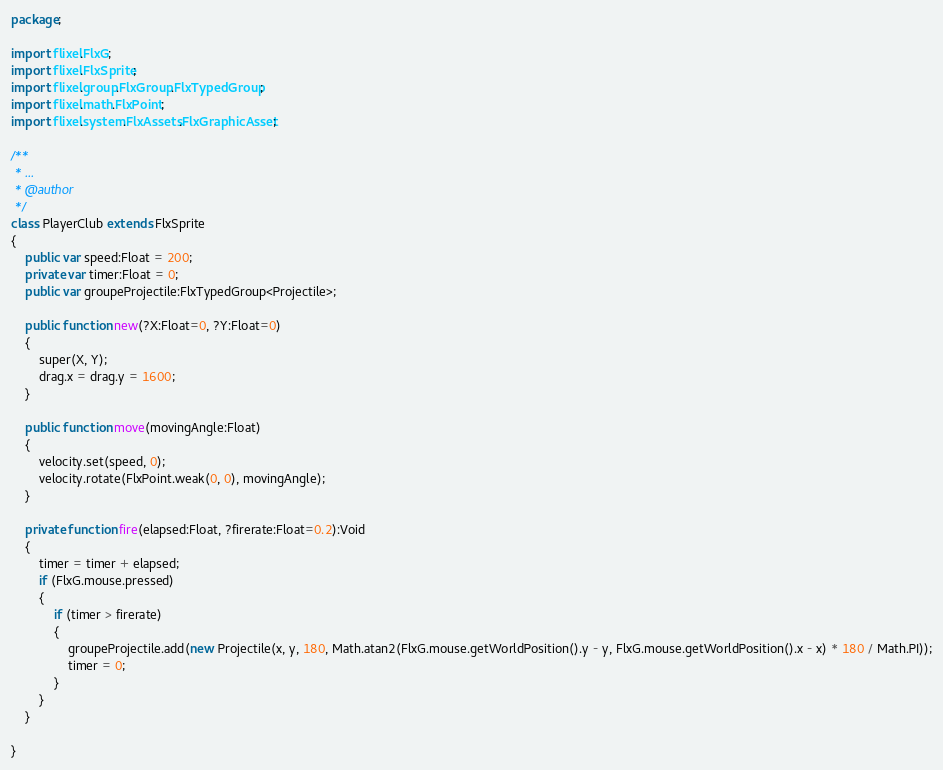Convert code to text. <code><loc_0><loc_0><loc_500><loc_500><_Haxe_>package;

import flixel.FlxG;
import flixel.FlxSprite;
import flixel.group.FlxGroup.FlxTypedGroup;
import flixel.math.FlxPoint;
import flixel.system.FlxAssets.FlxGraphicAsset;

/**
 * ...
 * @author 
 */
class PlayerClub extends FlxSprite 
{
	public var speed:Float = 200;
	private var timer:Float = 0;
	public var groupeProjectile:FlxTypedGroup<Projectile>;
	
	public function new(?X:Float=0, ?Y:Float=0) 
	{
		super(X, Y);
		drag.x = drag.y = 1600;
	}
	
	public function move(movingAngle:Float)
	{
		velocity.set(speed, 0);
		velocity.rotate(FlxPoint.weak(0, 0), movingAngle);
	}
	
	private function fire(elapsed:Float, ?firerate:Float=0.2):Void
	{
		timer = timer + elapsed;
		if (FlxG.mouse.pressed)
		{
			if (timer > firerate)
			{
				groupeProjectile.add(new Projectile(x, y, 180, Math.atan2(FlxG.mouse.getWorldPosition().y - y, FlxG.mouse.getWorldPosition().x - x) * 180 / Math.PI));
				timer = 0;
			}
		}
	}
	
}</code> 